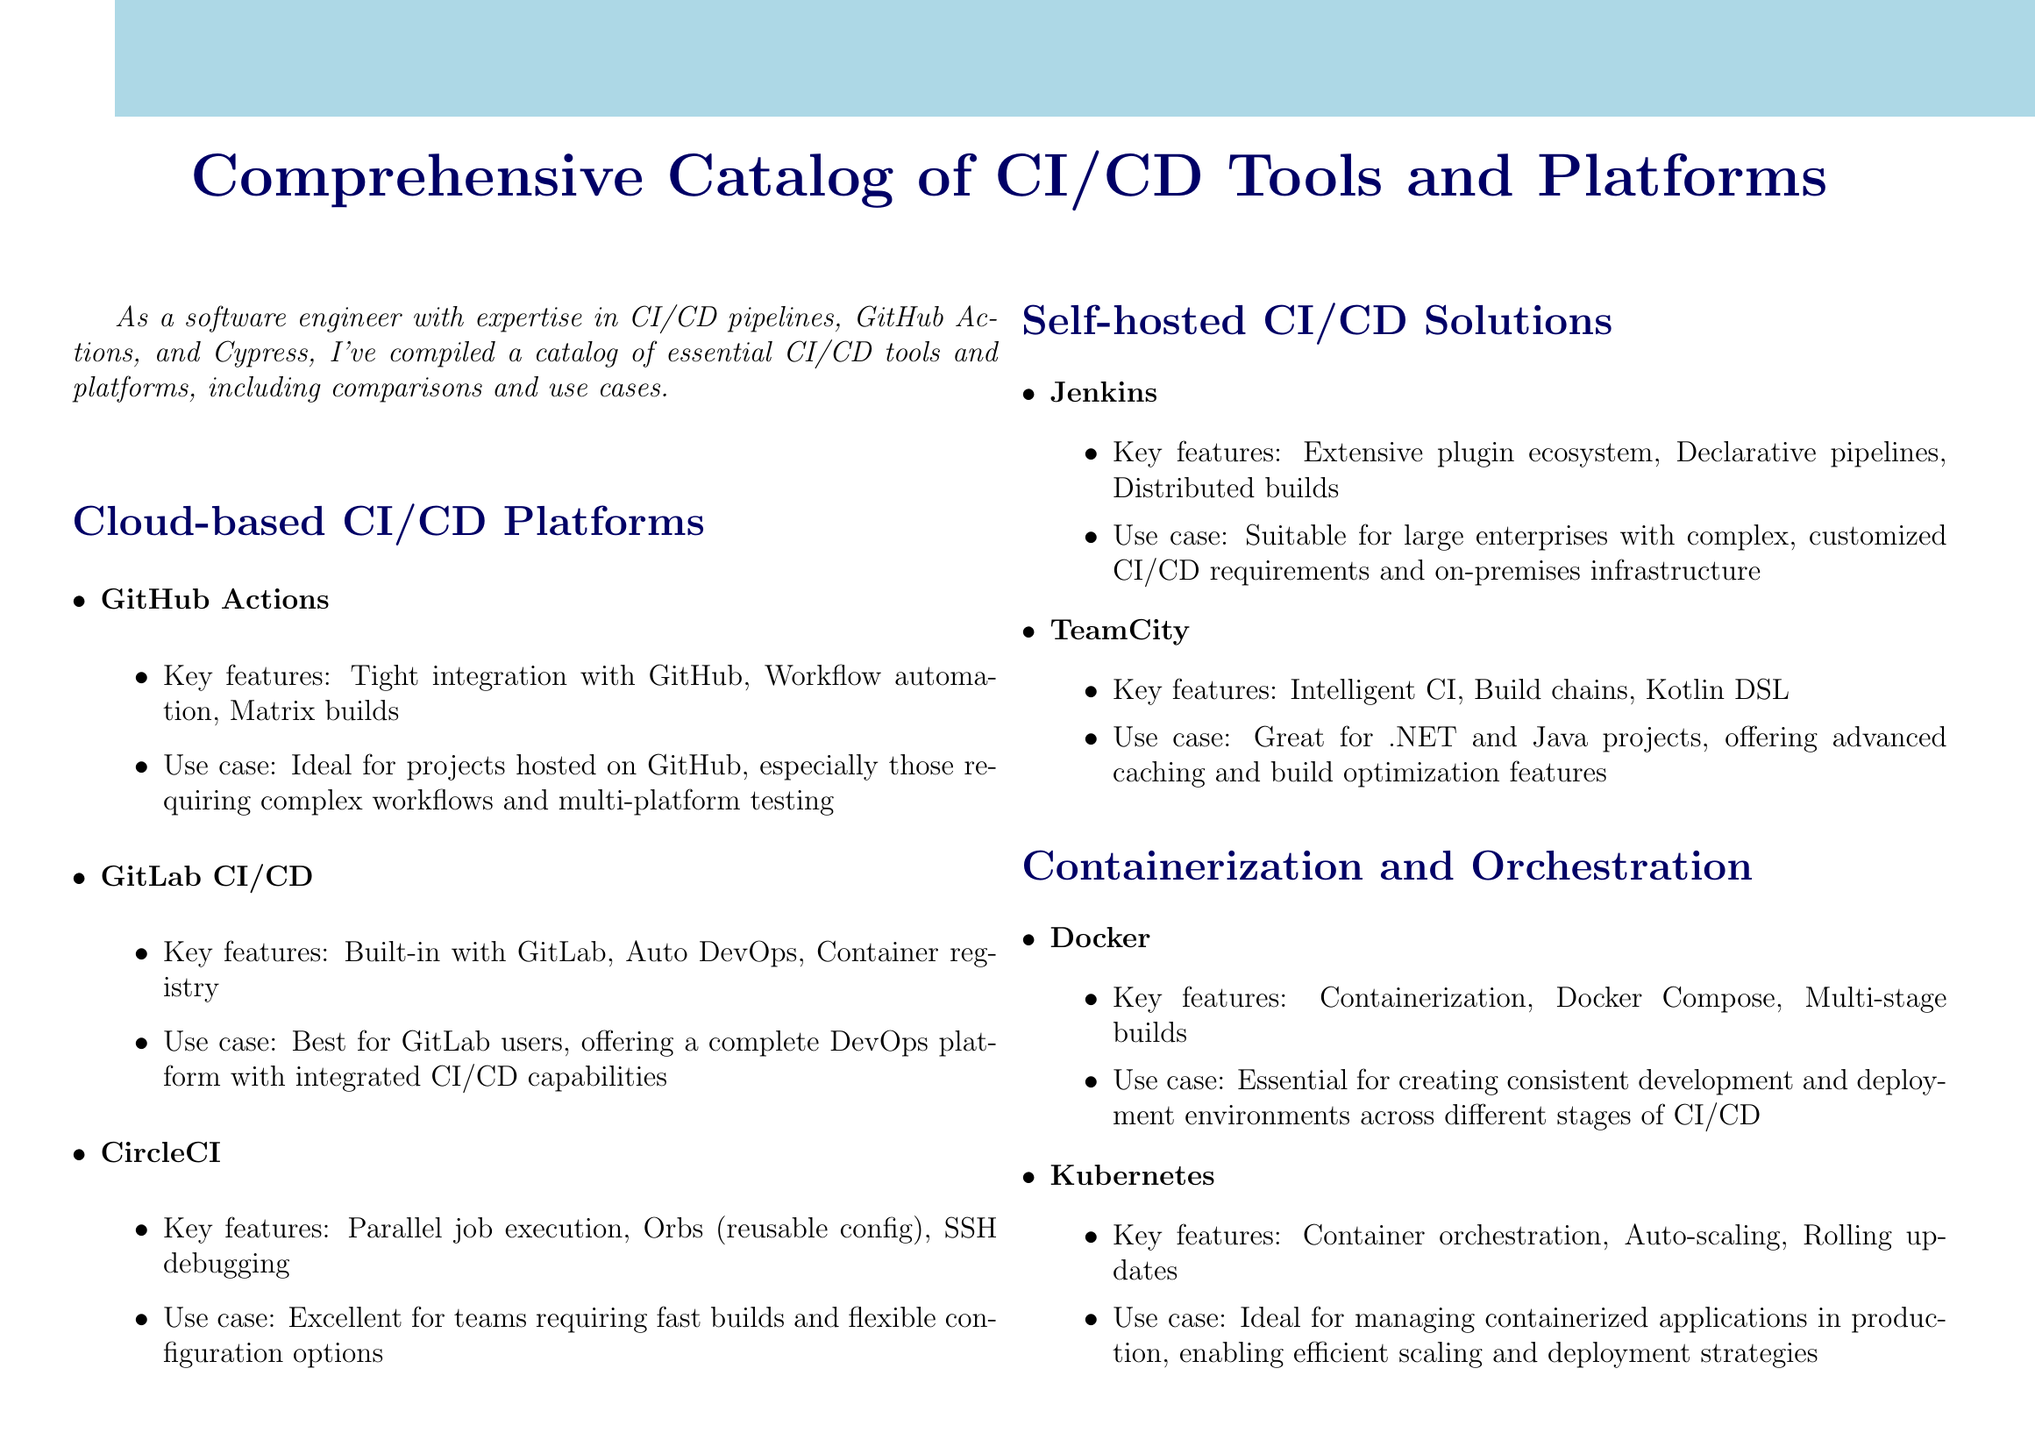What is a key feature of GitHub Actions? Key features are directly listed in the document, and one of them is tight integration with GitHub.
Answer: Tight integration with GitHub What use case is GitLab CI/CD best suited for? The use cases for each tool are explicitly mentioned, stating it is best for GitLab users.
Answer: GitLab users How many platforms are listed under Cloud-based CI/CD Platforms? The number of platforms listed can be counted in the document, and three are provided.
Answer: Three Which testing framework is described as perfect for modern web applications? The document specifies each testing framework's specific strengths, identifying Cypress as suitable for modern web applications.
Answer: Cypress What is the key feature of Kubernetes? The document lists key features of Kubernetes, and one is container orchestration.
Answer: Container orchestration What is a primary feature of Jenkins? The features listed for Jenkins reveal extensive plugin ecosystem as one of its primary attributes.
Answer: Extensive plugin ecosystem What is the use case for Docker in CI/CD? The document provides a specific use case for Docker, emphasizing its role in creating consistent environments.
Answer: Creating consistent environments How is TeamCity tailored for project environments? The document indicates TeamCity is great for .NET and Java projects, providing specific capabilities.
Answer: .NET and Java projects What does the conclusion of the catalog emphasize? The structure of the conclusion summarizing the choice considerations leads to the conclusion that focuses on project requirements.
Answer: Project requirements 